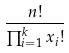<formula> <loc_0><loc_0><loc_500><loc_500>\frac { n ! } { \prod _ { i = 1 } ^ { k } x _ { i } ! }</formula> 